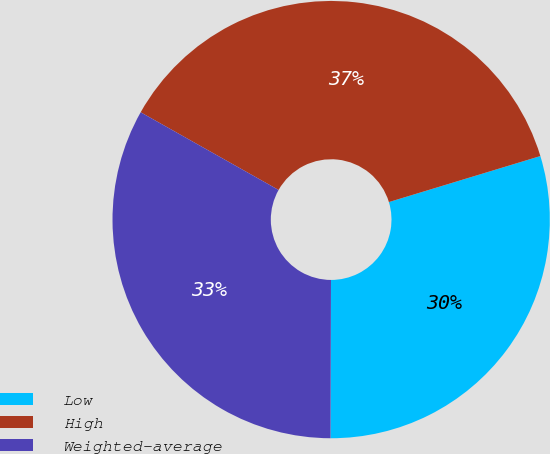<chart> <loc_0><loc_0><loc_500><loc_500><pie_chart><fcel>Low<fcel>High<fcel>Weighted-average<nl><fcel>29.74%<fcel>37.14%<fcel>33.12%<nl></chart> 